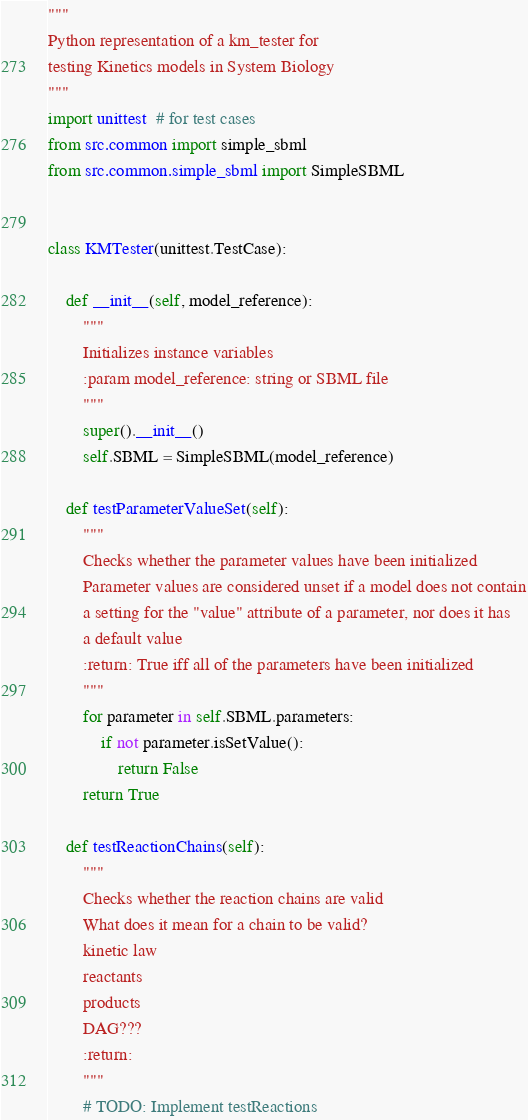Convert code to text. <code><loc_0><loc_0><loc_500><loc_500><_Python_>"""
Python representation of a km_tester for
testing Kinetics models in System Biology
"""
import unittest  # for test cases
from src.common import simple_sbml
from src.common.simple_sbml import SimpleSBML


class KMTester(unittest.TestCase):

    def __init__(self, model_reference):
        """
        Initializes instance variables
        :param model_reference: string or SBML file
        """
        super().__init__()
        self.SBML = SimpleSBML(model_reference)

    def testParameterValueSet(self):
        """
        Checks whether the parameter values have been initialized
        Parameter values are considered unset if a model does not contain
        a setting for the "value" attribute of a parameter, nor does it has
        a default value
        :return: True iff all of the parameters have been initialized
        """
        for parameter in self.SBML.parameters:
            if not parameter.isSetValue():
                return False
        return True

    def testReactionChains(self):
        """
        Checks whether the reaction chains are valid
        What does it mean for a chain to be valid?
        kinetic law
        reactants
        products
        DAG???
        :return:
        """
        # TODO: Implement testReactions</code> 